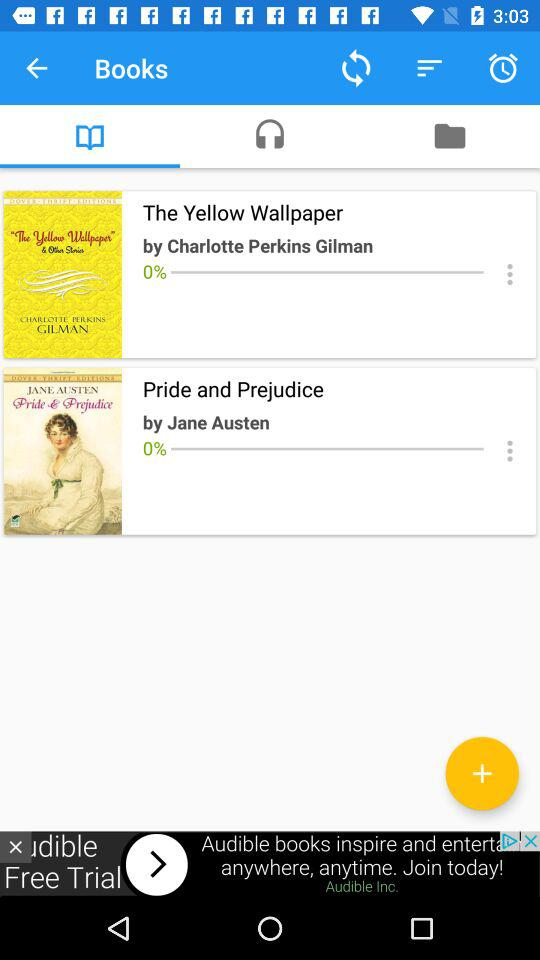Who wrote "Pride and Prejudice"? "Pride and Prejudice" was written by Jane Austen. 